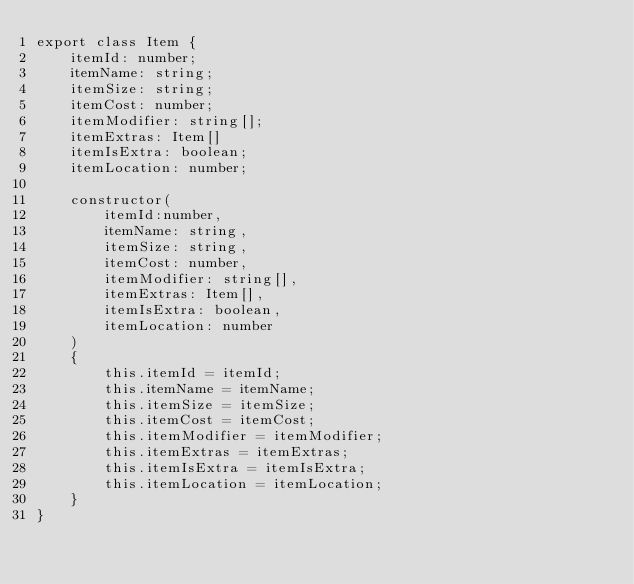<code> <loc_0><loc_0><loc_500><loc_500><_TypeScript_>export class Item {
    itemId: number;
    itemName: string;
    itemSize: string;
    itemCost: number;
    itemModifier: string[];
    itemExtras: Item[]
    itemIsExtra: boolean;
    itemLocation: number;

    constructor(
        itemId:number,
        itemName: string,
        itemSize: string,
        itemCost: number,
        itemModifier: string[],
        itemExtras: Item[],
        itemIsExtra: boolean,
        itemLocation: number
    )
    {
        this.itemId = itemId;
        this.itemName = itemName;
        this.itemSize = itemSize;
        this.itemCost = itemCost;
        this.itemModifier = itemModifier;
        this.itemExtras = itemExtras;
        this.itemIsExtra = itemIsExtra;
        this.itemLocation = itemLocation;
    }
}
</code> 